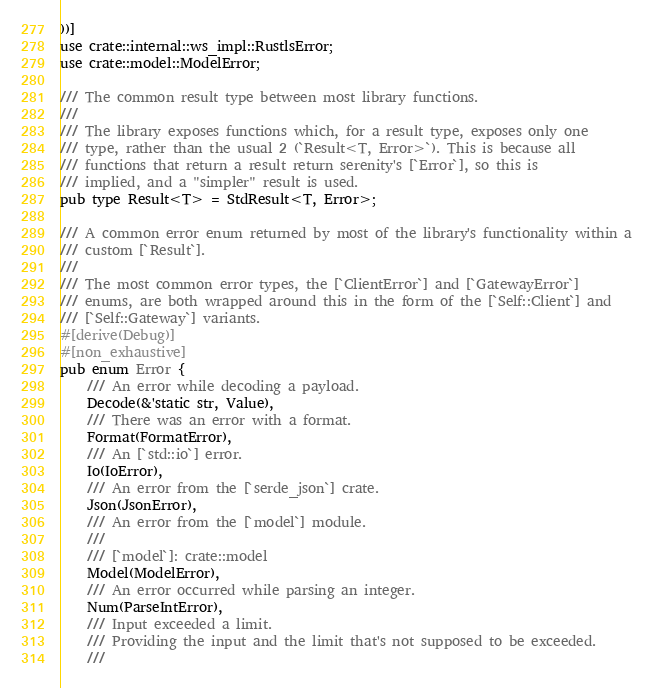Convert code to text. <code><loc_0><loc_0><loc_500><loc_500><_Rust_>))]
use crate::internal::ws_impl::RustlsError;
use crate::model::ModelError;

/// The common result type between most library functions.
///
/// The library exposes functions which, for a result type, exposes only one
/// type, rather than the usual 2 (`Result<T, Error>`). This is because all
/// functions that return a result return serenity's [`Error`], so this is
/// implied, and a "simpler" result is used.
pub type Result<T> = StdResult<T, Error>;

/// A common error enum returned by most of the library's functionality within a
/// custom [`Result`].
///
/// The most common error types, the [`ClientError`] and [`GatewayError`]
/// enums, are both wrapped around this in the form of the [`Self::Client`] and
/// [`Self::Gateway`] variants.
#[derive(Debug)]
#[non_exhaustive]
pub enum Error {
    /// An error while decoding a payload.
    Decode(&'static str, Value),
    /// There was an error with a format.
    Format(FormatError),
    /// An [`std::io`] error.
    Io(IoError),
    /// An error from the [`serde_json`] crate.
    Json(JsonError),
    /// An error from the [`model`] module.
    ///
    /// [`model`]: crate::model
    Model(ModelError),
    /// An error occurred while parsing an integer.
    Num(ParseIntError),
    /// Input exceeded a limit.
    /// Providing the input and the limit that's not supposed to be exceeded.
    ///</code> 